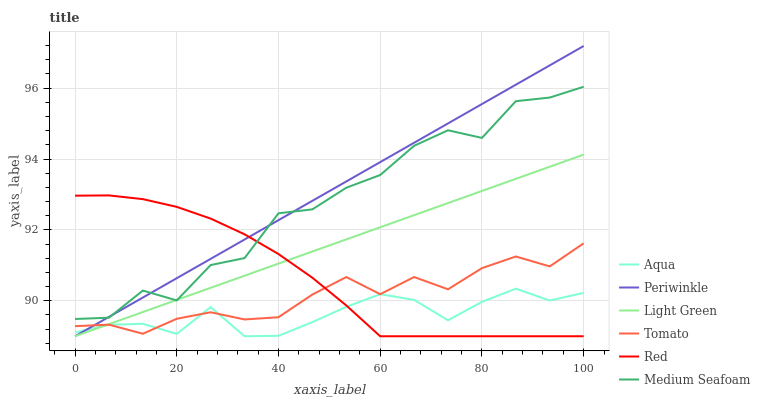Does Aqua have the minimum area under the curve?
Answer yes or no. Yes. Does Periwinkle have the maximum area under the curve?
Answer yes or no. Yes. Does Periwinkle have the minimum area under the curve?
Answer yes or no. No. Does Aqua have the maximum area under the curve?
Answer yes or no. No. Is Periwinkle the smoothest?
Answer yes or no. Yes. Is Medium Seafoam the roughest?
Answer yes or no. Yes. Is Aqua the smoothest?
Answer yes or no. No. Is Aqua the roughest?
Answer yes or no. No. Does Medium Seafoam have the lowest value?
Answer yes or no. No. Does Periwinkle have the highest value?
Answer yes or no. Yes. Does Aqua have the highest value?
Answer yes or no. No. Is Aqua less than Medium Seafoam?
Answer yes or no. Yes. Is Medium Seafoam greater than Tomato?
Answer yes or no. Yes. Does Red intersect Medium Seafoam?
Answer yes or no. Yes. Is Red less than Medium Seafoam?
Answer yes or no. No. Is Red greater than Medium Seafoam?
Answer yes or no. No. Does Aqua intersect Medium Seafoam?
Answer yes or no. No. 